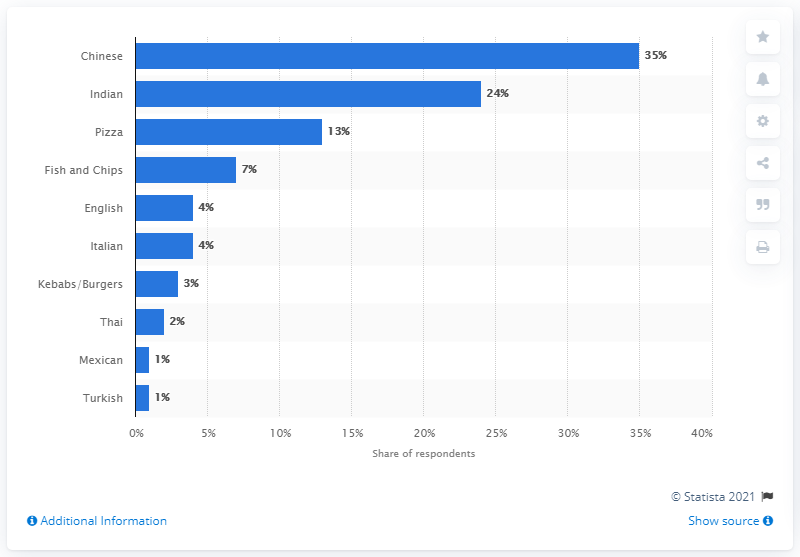Indicate a few pertinent items in this graphic. According to a survey conducted in the UK in 2017, Chinese takeaway food was the most popular among consumers. 